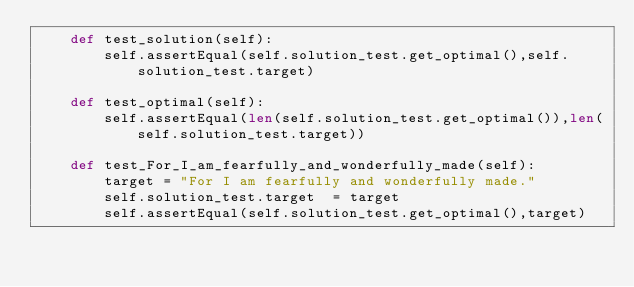Convert code to text. <code><loc_0><loc_0><loc_500><loc_500><_Python_>    def test_solution(self):
        self.assertEqual(self.solution_test.get_optimal(),self.solution_test.target)

    def test_optimal(self):
        self.assertEqual(len(self.solution_test.get_optimal()),len(self.solution_test.target))

    def test_For_I_am_fearfully_and_wonderfully_made(self):
        target = "For I am fearfully and wonderfully made."
        self.solution_test.target  = target
        self.assertEqual(self.solution_test.get_optimal(),target)</code> 